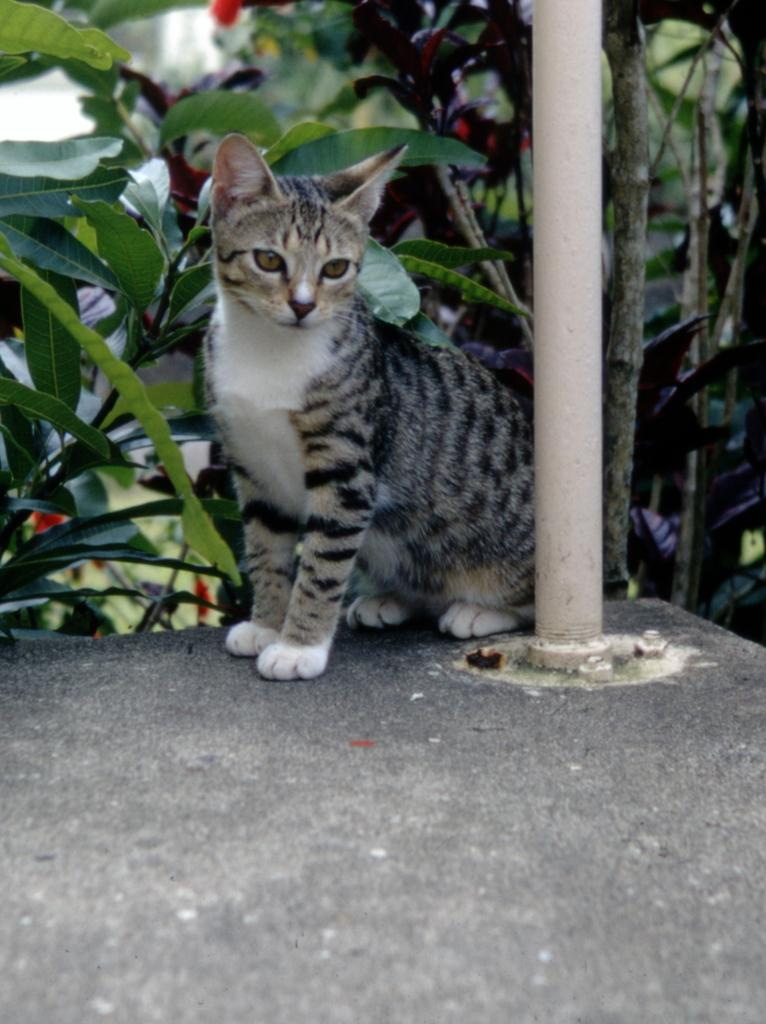What animal is in the middle of the image? There is a cat in the middle of the image. What is located near the cat? There are plants beside the cat. What type of object can be seen in the image? There is a metal rod in the image. How many babies are visible in the image? There are no babies present in the image. Can you find a receipt in the image? There is no receipt present in the image. 